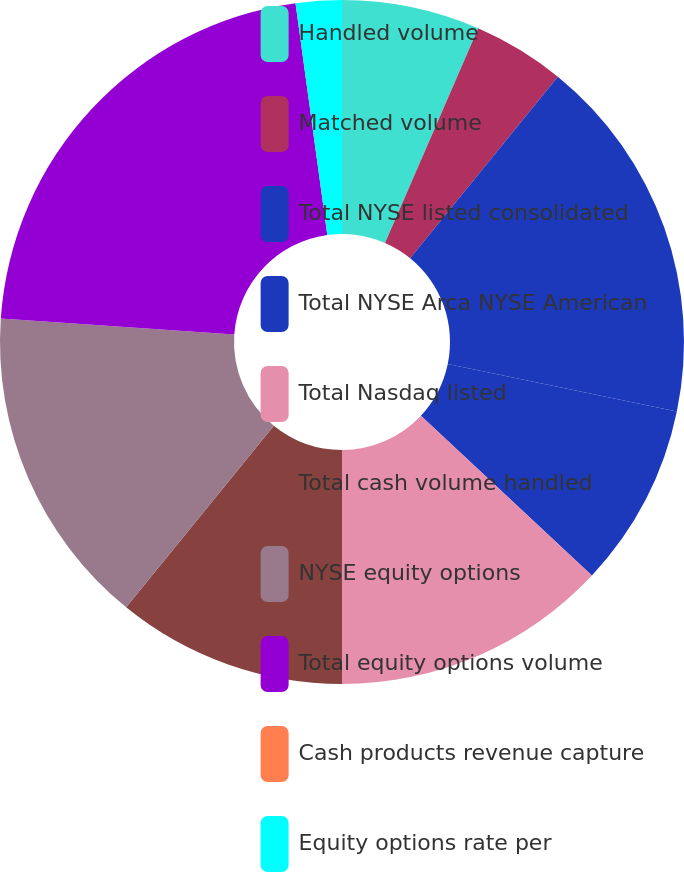<chart> <loc_0><loc_0><loc_500><loc_500><pie_chart><fcel>Handled volume<fcel>Matched volume<fcel>Total NYSE listed consolidated<fcel>Total NYSE Arca NYSE American<fcel>Total Nasdaq listed<fcel>Total cash volume handled<fcel>NYSE equity options<fcel>Total equity options volume<fcel>Cash products revenue capture<fcel>Equity options rate per<nl><fcel>6.52%<fcel>4.35%<fcel>17.39%<fcel>8.7%<fcel>13.04%<fcel>10.87%<fcel>15.22%<fcel>21.74%<fcel>0.0%<fcel>2.17%<nl></chart> 